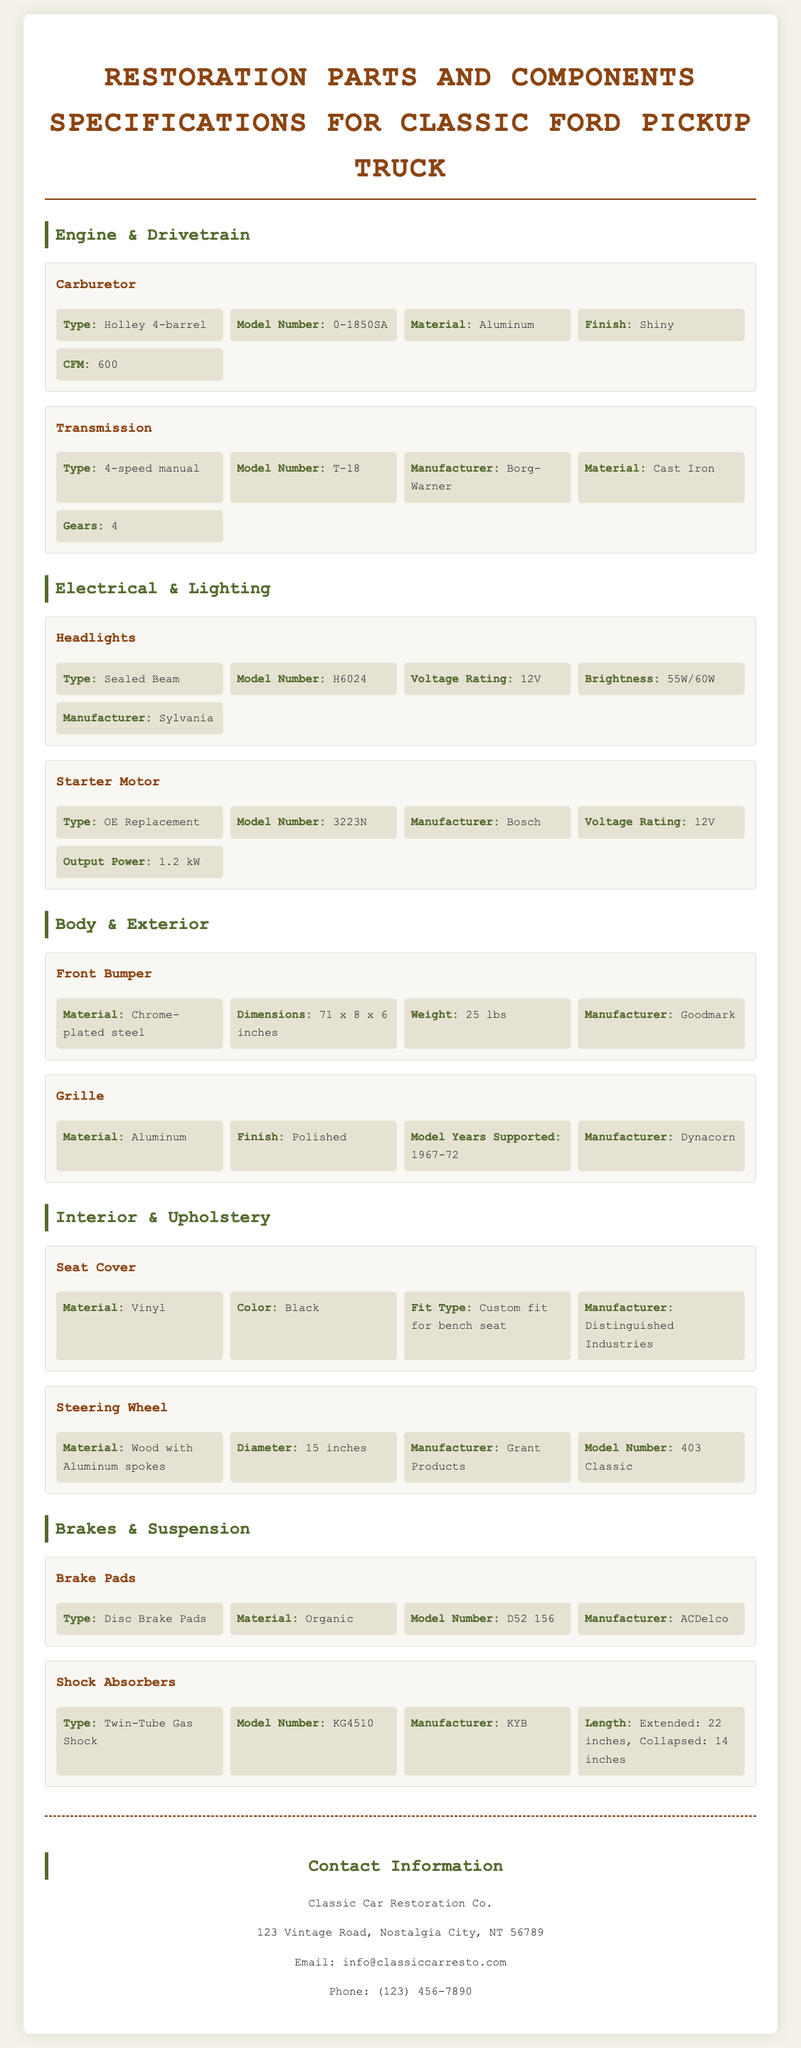What is the type of carburetor? The type of carburetor is specified as "Holley 4-barrel" in the document.
Answer: Holley 4-barrel What is the model number of the transmission? The model number of the transmission is "T-18" as stated in the specifications.
Answer: T-18 What is the material of the front bumper? The document specifies that the front bumper is made of "Chrome-plated steel."
Answer: Chrome-plated steel What is the voltage rating of the starter motor? The voltage rating of the starter motor is indicated as "12V" in the document.
Answer: 12V How much does the front bumper weigh? The weight of the front bumper is noted as "25 lbs" according to the specifications.
Answer: 25 lbs What type are the brake pads? The type of brake pads is described as "Disc Brake Pads" in the document.
Answer: Disc Brake Pads Which manufacturer makes the headlights? The manufacturer of the headlights is specified as "Sylvania" in the document.
Answer: Sylvania What is the extended length of the shock absorbers? The extended length of the shock absorbers is "22 inches" as provided in the specifications.
Answer: 22 inches What is the color of the seat cover? The color of the seat cover is specified as "Black" in the document.
Answer: Black 